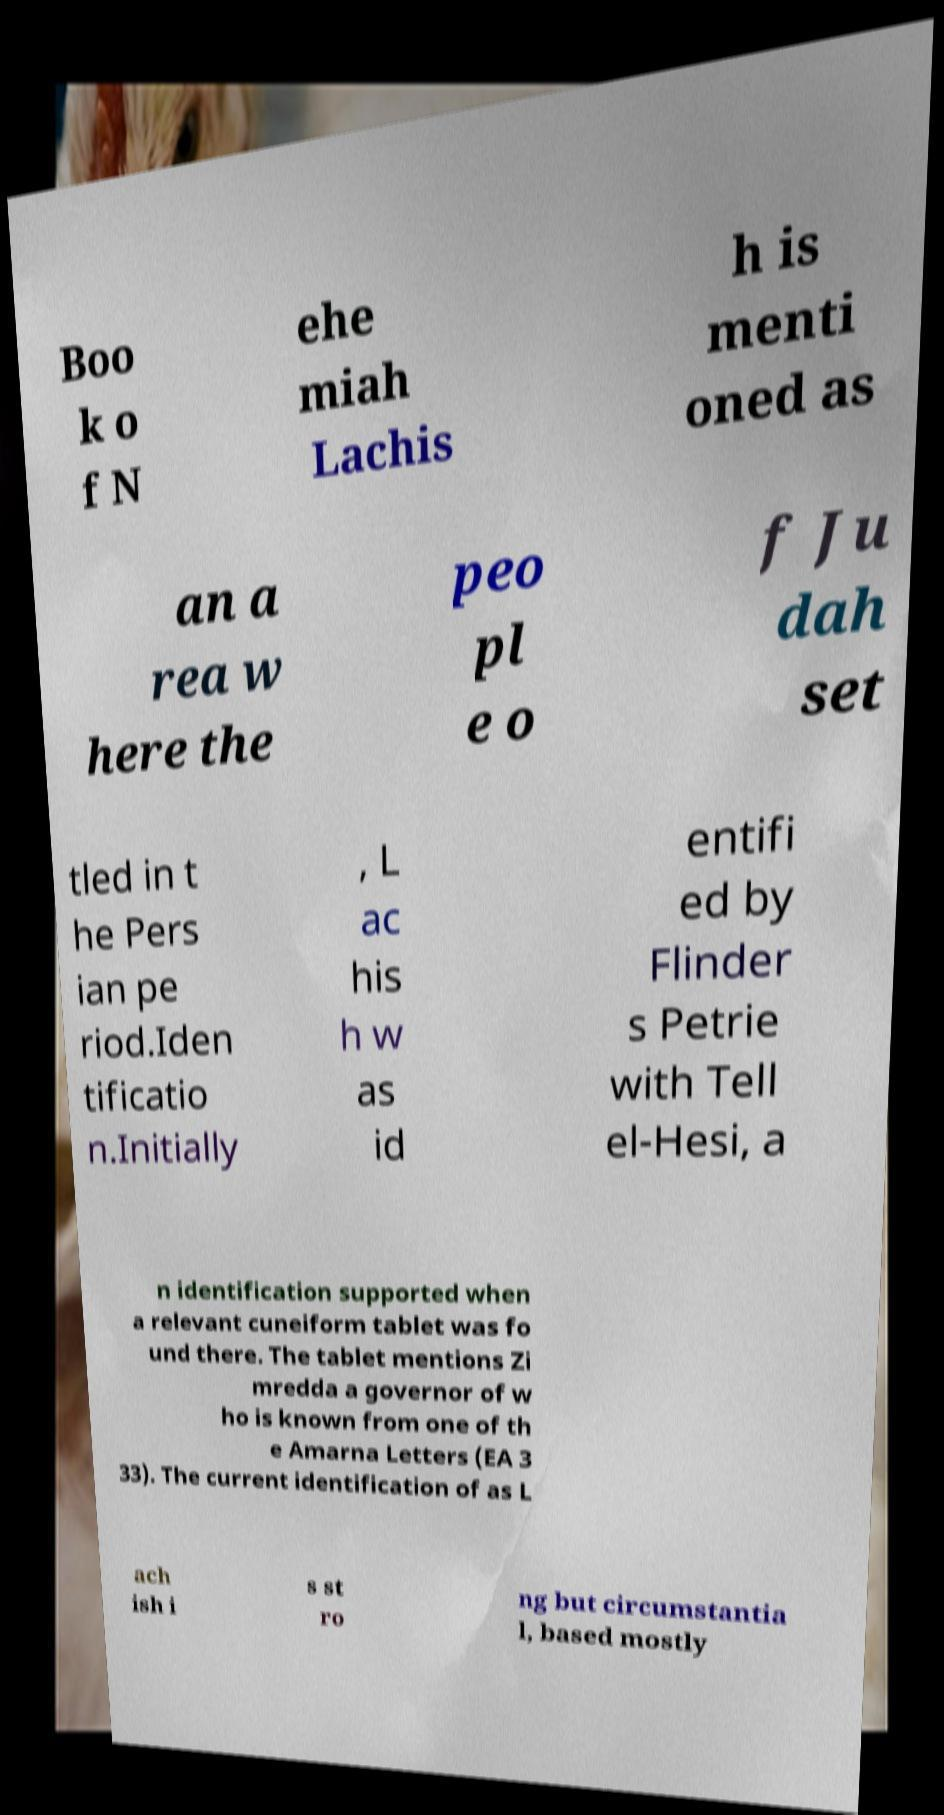There's text embedded in this image that I need extracted. Can you transcribe it verbatim? Boo k o f N ehe miah Lachis h is menti oned as an a rea w here the peo pl e o f Ju dah set tled in t he Pers ian pe riod.Iden tificatio n.Initially , L ac his h w as id entifi ed by Flinder s Petrie with Tell el-Hesi, a n identification supported when a relevant cuneiform tablet was fo und there. The tablet mentions Zi mredda a governor of w ho is known from one of th e Amarna Letters (EA 3 33). The current identification of as L ach ish i s st ro ng but circumstantia l, based mostly 